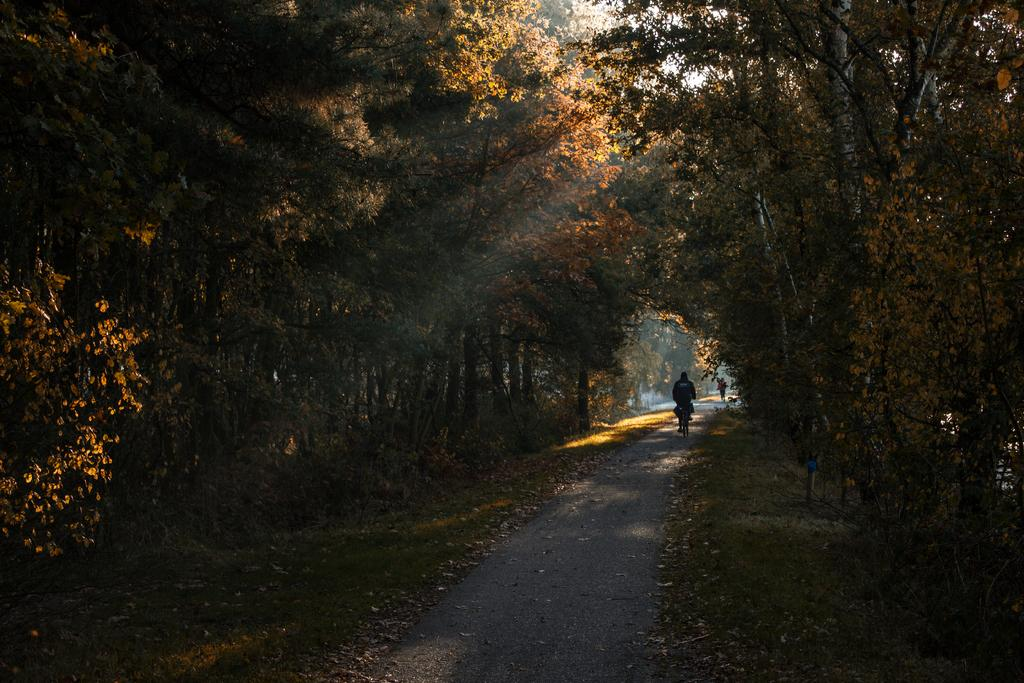What is the main feature of the image? There is a road in the image. What can be seen alongside the road? Trees are present alongside the road. What is the person in the image doing? The person is riding a bicycle. How many trips did the person take during their holiday in the image? There is no information about a holiday or trips in the image; it only shows a person riding a bicycle on a road with trees alongside it. 